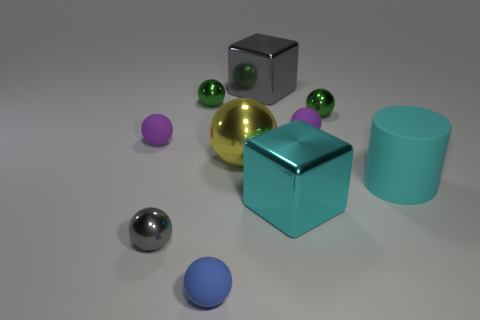Are there the same number of tiny rubber balls that are to the left of the big yellow ball and shiny balls that are on the left side of the blue ball?
Your answer should be very brief. Yes. Are there any spheres of the same size as the blue matte object?
Keep it short and to the point. Yes. How big is the cyan rubber thing?
Ensure brevity in your answer.  Large. Are there the same number of large cyan metallic objects on the left side of the large cyan matte cylinder and tiny gray metal things?
Provide a short and direct response. Yes. How many other things are the same color as the large matte object?
Offer a very short reply. 1. What is the color of the small metallic ball that is both on the left side of the big cyan cube and behind the small gray ball?
Provide a short and direct response. Green. How big is the yellow object in front of the purple rubber object on the left side of the small rubber object in front of the cyan matte cylinder?
Give a very brief answer. Large. How many things are either big cyan matte cylinders to the right of the big ball or big shiny objects in front of the cyan rubber object?
Offer a terse response. 2. The blue object has what shape?
Your answer should be very brief. Sphere. How many other things are the same material as the large sphere?
Give a very brief answer. 5. 